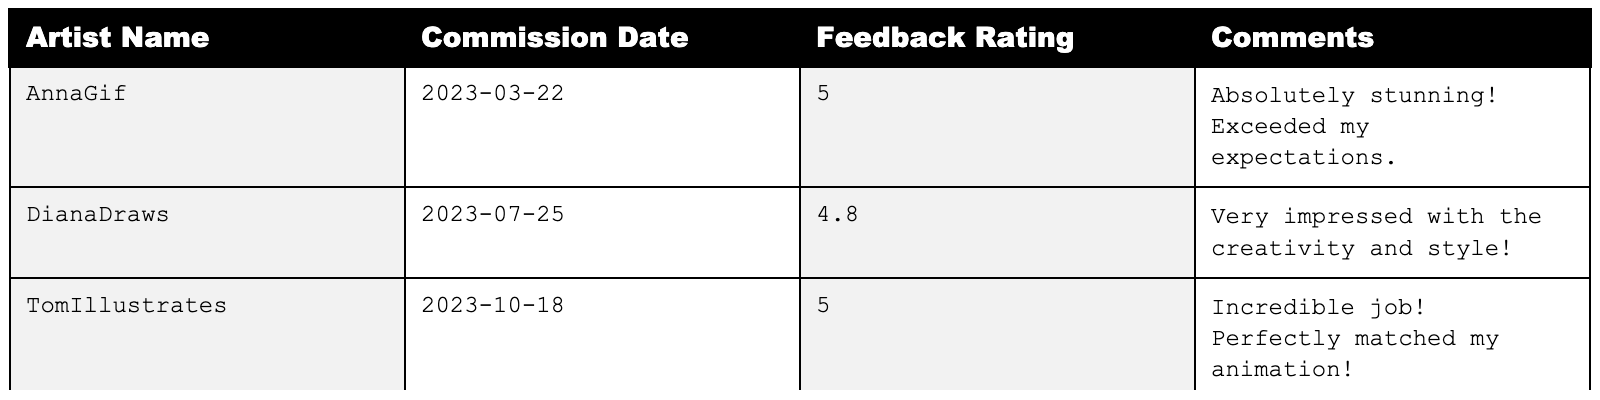What is the highest feedback rating received? The table shows the feedback ratings, and the highest value is 5.0 from both AnnaGif and TomIllustrates.
Answer: 5.0 What are the comments given by DianaDraws? Referring to the table, DianaDraws provided the comment, "Very impressed with the creativity and style!"
Answer: Very impressed with the creativity and style! How many feedback ratings are above 4.5? There are three ratings (5.0, 4.8, and 5.0) that are above 4.5, counting them from the table.
Answer: 3 What is the average feedback rating from the table? The ratings are 5.0, 4.8, and 5.0. Calculating the average: (5.0 + 4.8 + 5.0) / 3 = 4.9333, approximately 4.93 when rounded to two decimal places.
Answer: 4.93 Did all artists provide a feedback rating of 5.0? No, the table shows that DianaDraws rated the illustration 4.8, which is not 5.0.
Answer: No Which artist had the earliest commission date? The commission dates are 2023-03-22 (AnnaGif), 2023-07-25 (DianaDraws), and 2023-10-18 (TomIllustrates). The earliest date is 2023-03-22 from AnnaGif.
Answer: AnnaGif What percentage of the feedback ratings is 5.0? There are three total ratings and two ratings of 5.0. Calculating the percentage: (2 / 3) * 100 = 66.67%.
Answer: 66.67% Which artist commented on the creativity of the illustration? DianaDraws commented on the creativity, stating, "Very impressed with the creativity and style!"
Answer: DianaDraws If the lowest rating increases by 0.2, what would its new value be? The lowest rating is 4.8 (given by DianaDraws). Adding 0.2 gives 4.8 + 0.2 = 5.0.
Answer: 5.0 How many artists made comments indicating they were impressed? Both AnnaGif and DianaDraws express their satisfaction with the work ("Absolutely stunning! Exceeded my expectations." and "Very impressed with the creativity and style!"). Hence, two artists made such comments.
Answer: 2 